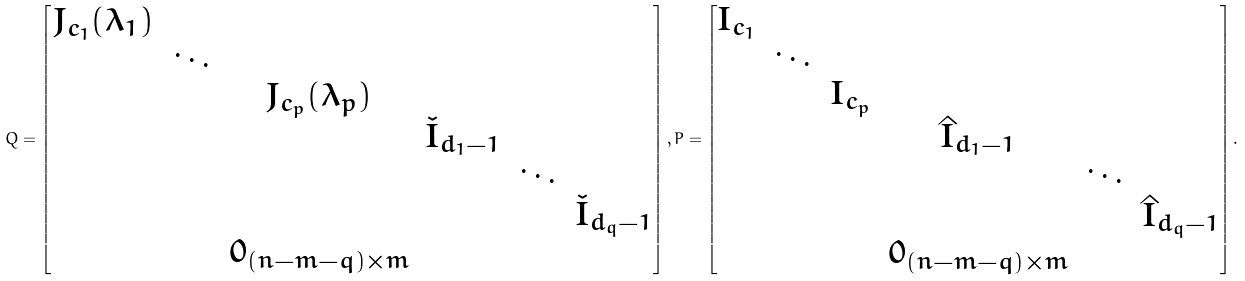<formula> <loc_0><loc_0><loc_500><loc_500>Q = \begin{bmatrix} J _ { c _ { 1 } } ( \lambda _ { 1 } ) \\ & \ddots \\ & & J _ { c _ { p } } ( \lambda _ { p } ) \\ & & & \check { I } _ { d _ { 1 } - 1 } \\ & & & & \ddots \\ & & & & & \check { I } _ { d _ { q } - 1 } \\ & & 0 _ { ( n - m - q ) \times m } \end{bmatrix} , P = \begin{bmatrix} I _ { c _ { 1 } } \\ & \ddots \\ & & I _ { c _ { p } } \\ & & & \hat { I } _ { d _ { 1 } - 1 } \\ & & & & \ddots \\ & & & & & \hat { I } _ { d _ { q } - 1 } \\ & & & 0 _ { ( n - m - q ) \times m } \end{bmatrix} .</formula> 